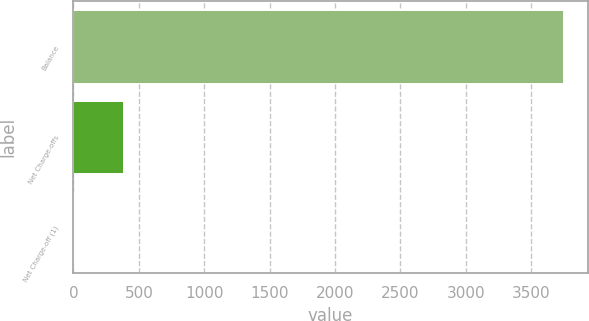<chart> <loc_0><loc_0><loc_500><loc_500><bar_chart><fcel>Balance<fcel>Net Charge-offs<fcel>Net Charge-off (1)<nl><fcel>3745<fcel>375.81<fcel>1.45<nl></chart> 